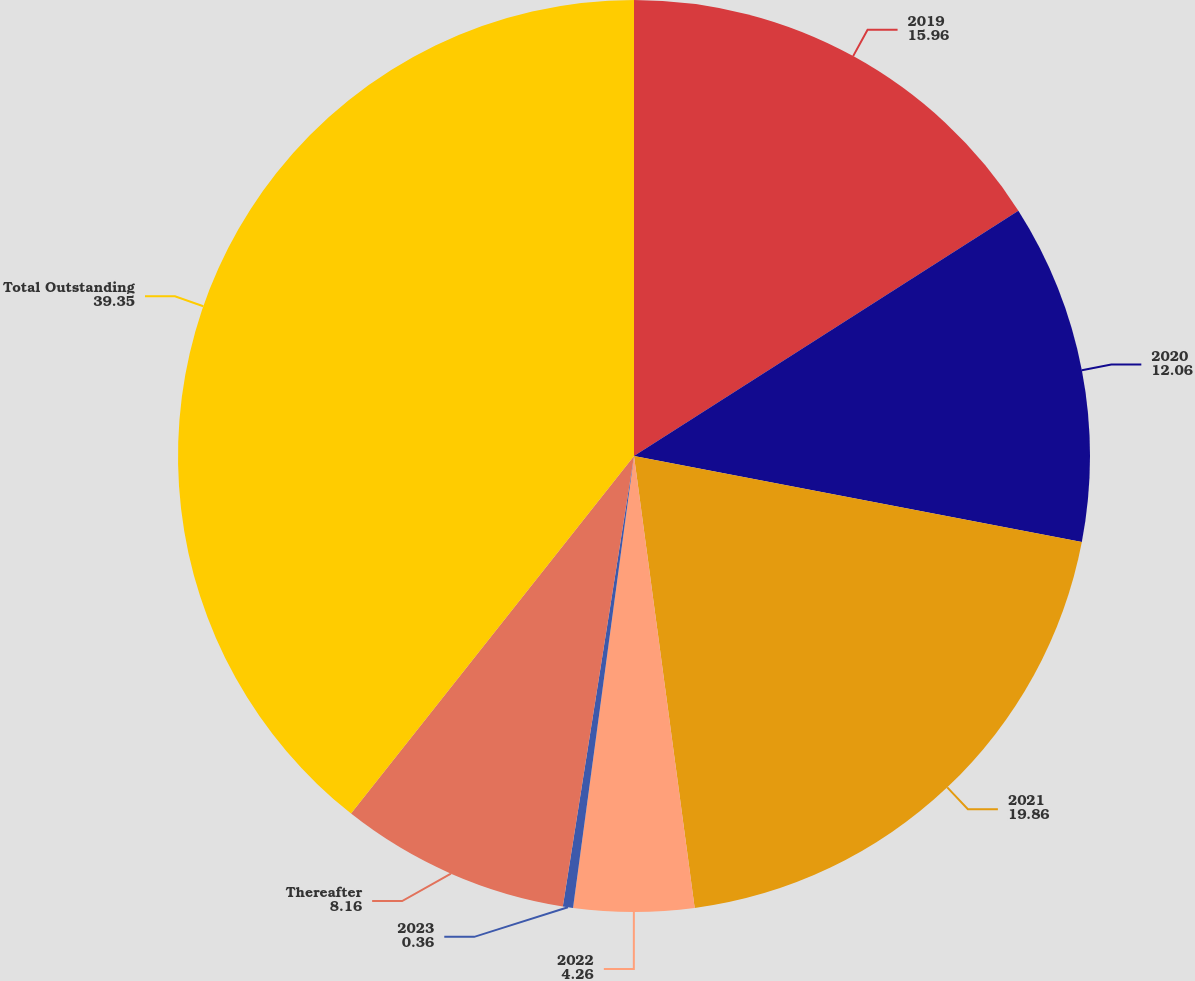<chart> <loc_0><loc_0><loc_500><loc_500><pie_chart><fcel>2019<fcel>2020<fcel>2021<fcel>2022<fcel>2023<fcel>Thereafter<fcel>Total Outstanding<nl><fcel>15.96%<fcel>12.06%<fcel>19.86%<fcel>4.26%<fcel>0.36%<fcel>8.16%<fcel>39.35%<nl></chart> 